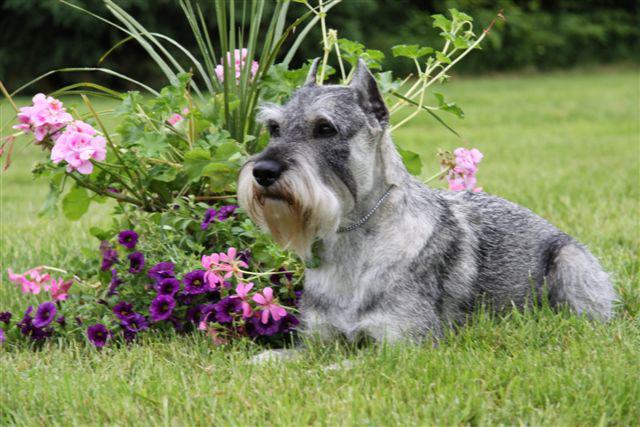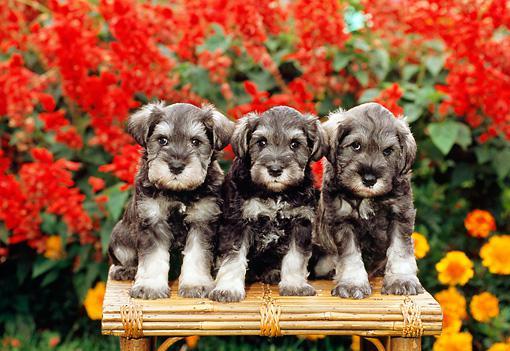The first image is the image on the left, the second image is the image on the right. Evaluate the accuracy of this statement regarding the images: "There are at most two dogs.". Is it true? Answer yes or no. No. The first image is the image on the left, the second image is the image on the right. Considering the images on both sides, is "An image contains at least three dogs." valid? Answer yes or no. Yes. 